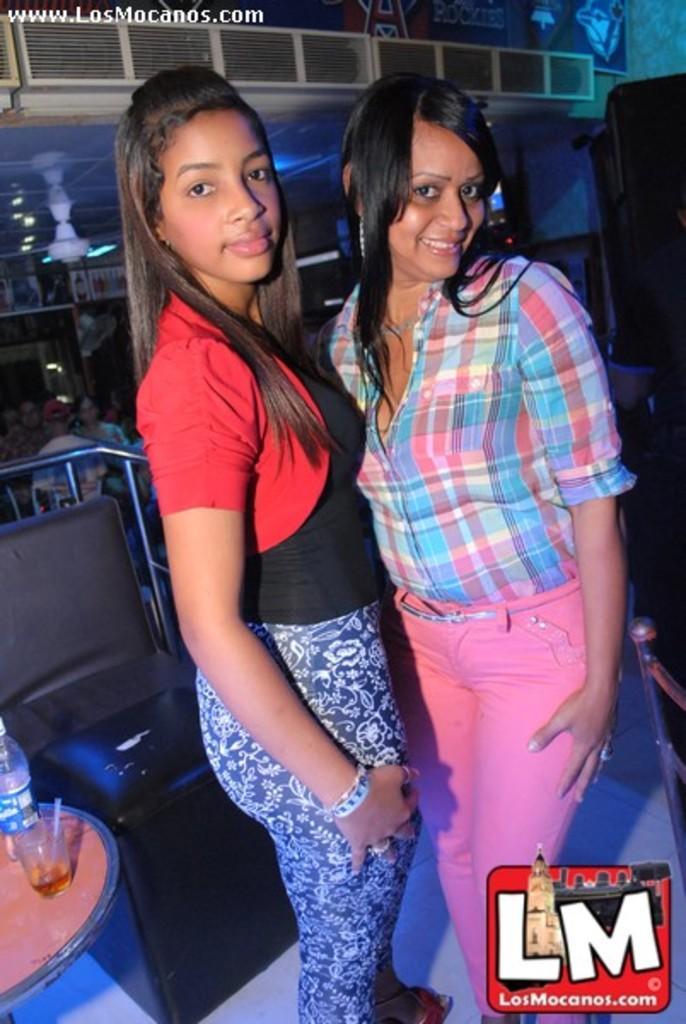Can you describe this image briefly? In this picture we can see two women are taking picture, side there is a glass and bottle are placed on the table, behind we can see some people are sitting on the chairs. 